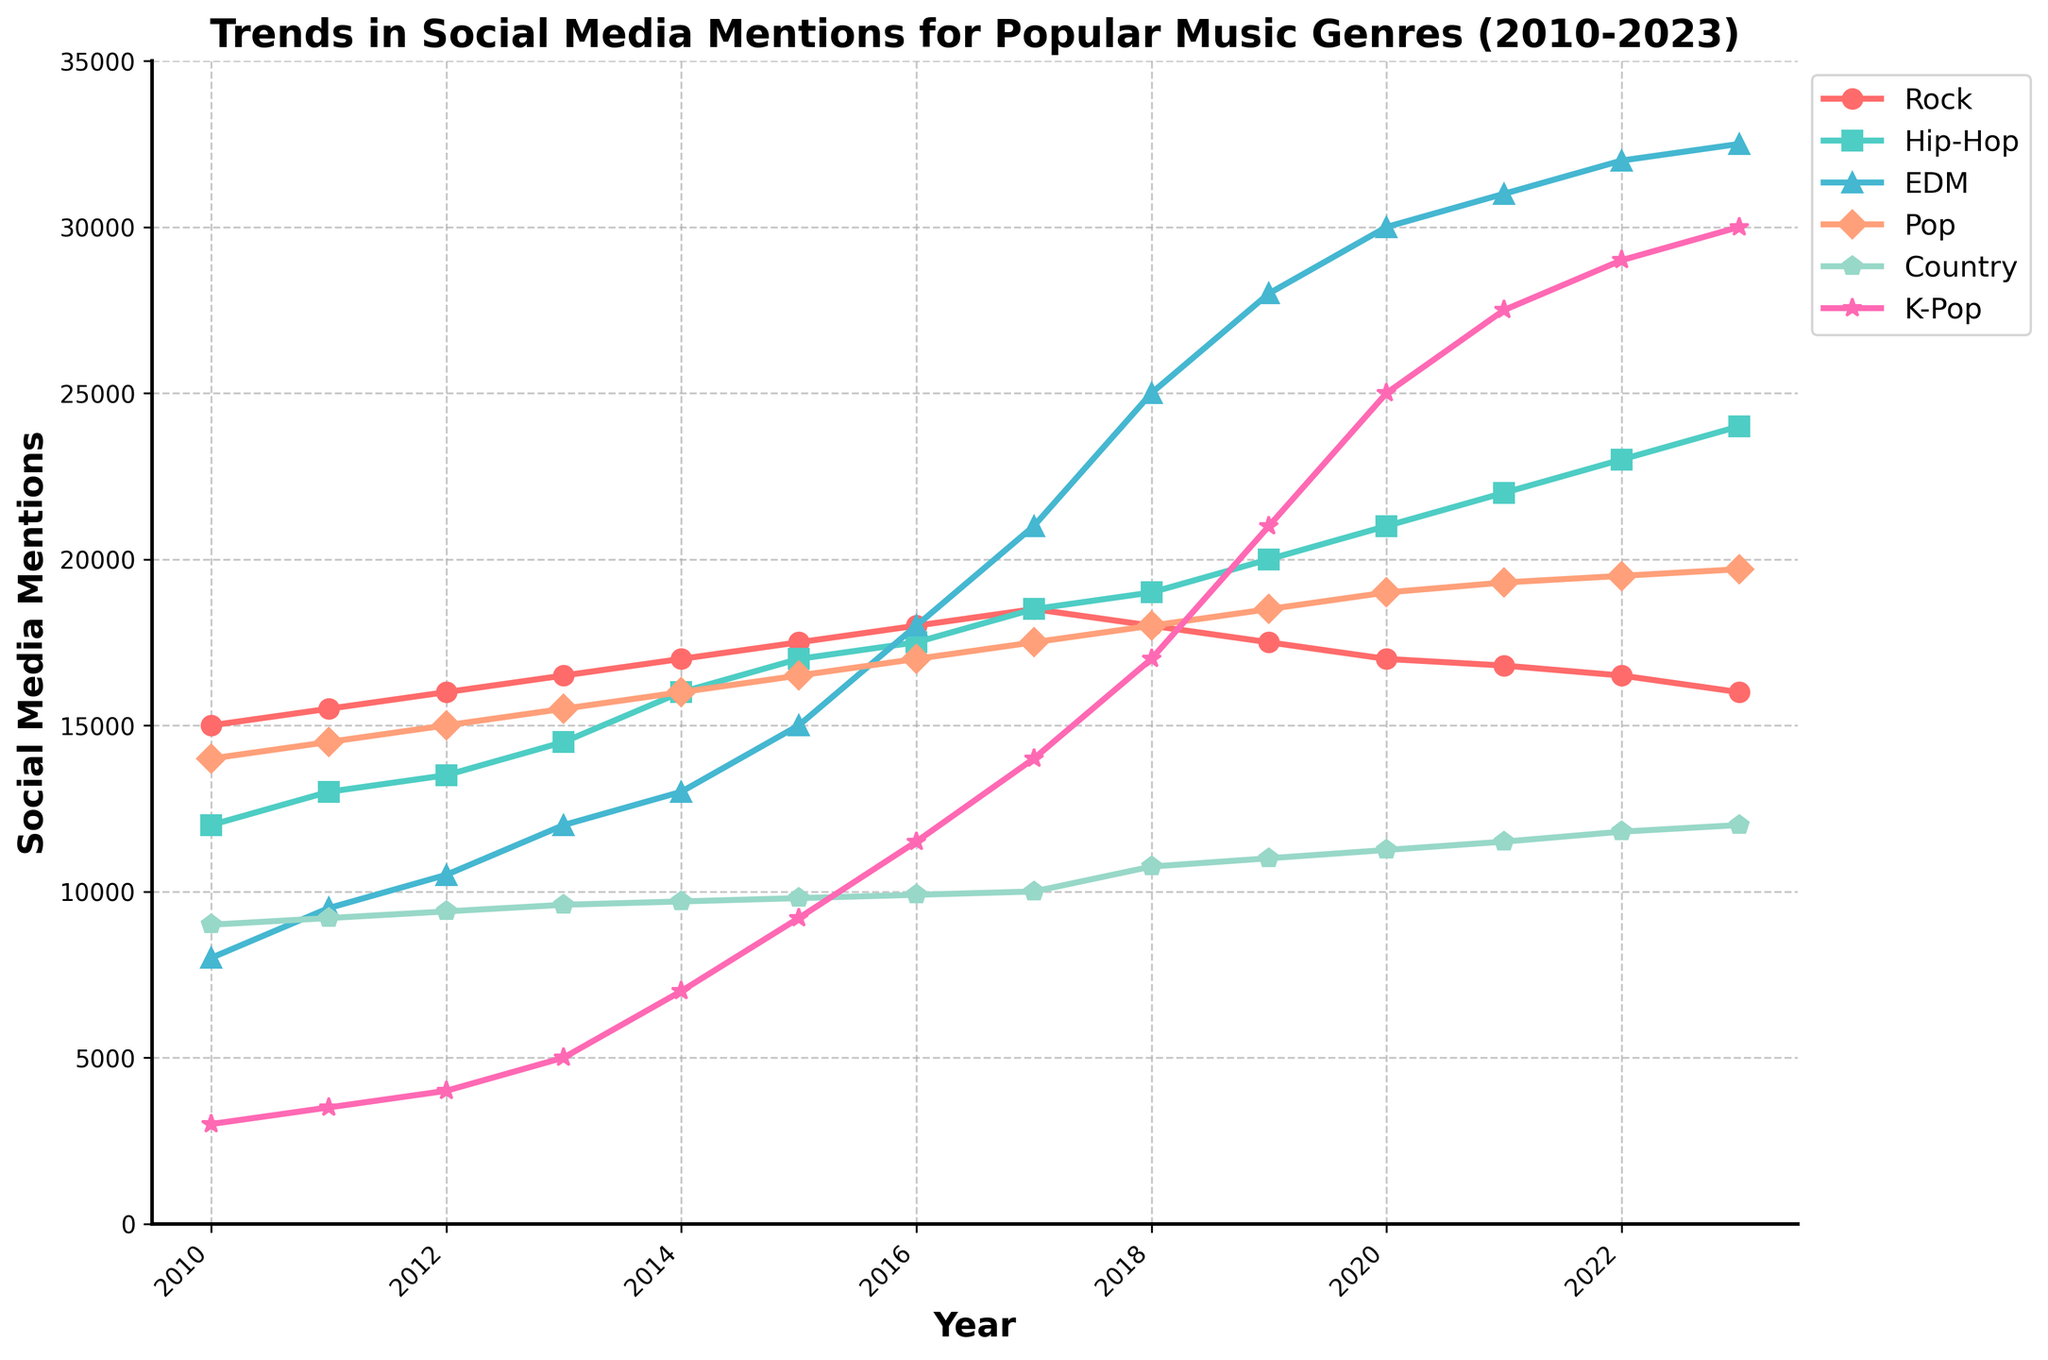Which music genre had the highest number of social media mentions in 2010? Look at the data points for the year 2010 on the y-axis, then find the corresponding genre with the highest value. Rock (15000) has the highest mentions.
Answer: Rock Between 2010 and 2023, which genre shows the most significant overall increase in mentions? Subtract the number of mentions in 2010 from the number of mentions in 2023 for each genre. The genre with the highest difference is the one with the most significant increase. K-Pop shows an increase from 3000 to 30000 (difference of 27000).
Answer: K-Pop Which genre had a decrease in social media mentions from 2017 to 2023? Compare the number of mentions in 2017 and 2023 for each genre. Rock decreased from 18500 (2017) to 16000 (2023).
Answer: Rock What is the average number of mentions for EDM from 2010 to 2023? Sum all the mentions of EDM from 2010 to 2023 and divide by the number of years (14). The total is 320000, so 320000 / 14 = 22857.14.
Answer: 22857.14 Which genres had a higher number of mentions than Pop in 2021? Find the number of Pop mentions in 2021 (19300) and compare it to other genres' mentions in the same year. Hip-Hop (22000), EDM (31000), and K-Pop (27500) are higher than Pop.
Answer: Hip-Hop, EDM, K-Pop Between Pop and EDM, which genre shows a more consistent increase in mentions from 2010 to 2023? Analyze both time series. Pop shows a relatively linear increase, while EDM shows a more rapid increase, especially between 2016 and 2023. Therefore, Pop is more consistent.
Answer: Pop What is the trend for Country music mentions from 2010 to 2023? Look at the data points for Country music from 2010 to 2023. The mentions show a steady but slow increase.
Answer: Steady increase In which year did Hip-Hop surpass Rock in social media mentions? Compare the data points for Hip-Hop and Rock each year. In 2019, Hip-Hop (20000) surpassed Rock (17500).
Answer: 2019 What is the maximum number of mentions for any genre within the period 2010-2023? Identify the highest single data point from all genres and years. The maximum number is 32500 for EDM in 2023.
Answer: 32500 